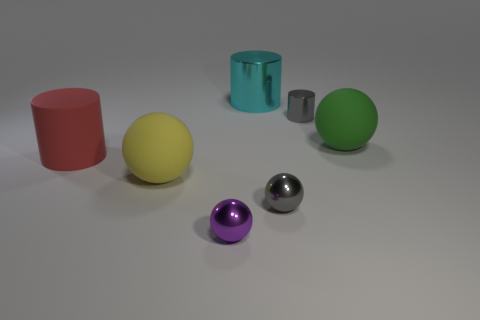What number of small objects are the same color as the tiny cylinder?
Keep it short and to the point. 1. There is another sphere that is the same size as the gray sphere; what is its color?
Your answer should be compact. Purple. How many tiny gray shiny cylinders are on the right side of the purple object?
Give a very brief answer. 1. Are any blue shiny cubes visible?
Offer a very short reply. No. There is a ball to the right of the small sphere that is to the right of the tiny object on the left side of the large cyan cylinder; what is its size?
Offer a terse response. Large. What number of other objects are the same size as the yellow matte ball?
Your response must be concise. 3. What is the size of the rubber sphere that is left of the large green matte object?
Offer a terse response. Large. Are there any other things that have the same color as the large rubber cylinder?
Offer a very short reply. No. Does the tiny gray object behind the yellow matte object have the same material as the small purple sphere?
Offer a terse response. Yes. How many things are in front of the cyan cylinder and on the right side of the red matte cylinder?
Offer a very short reply. 5. 